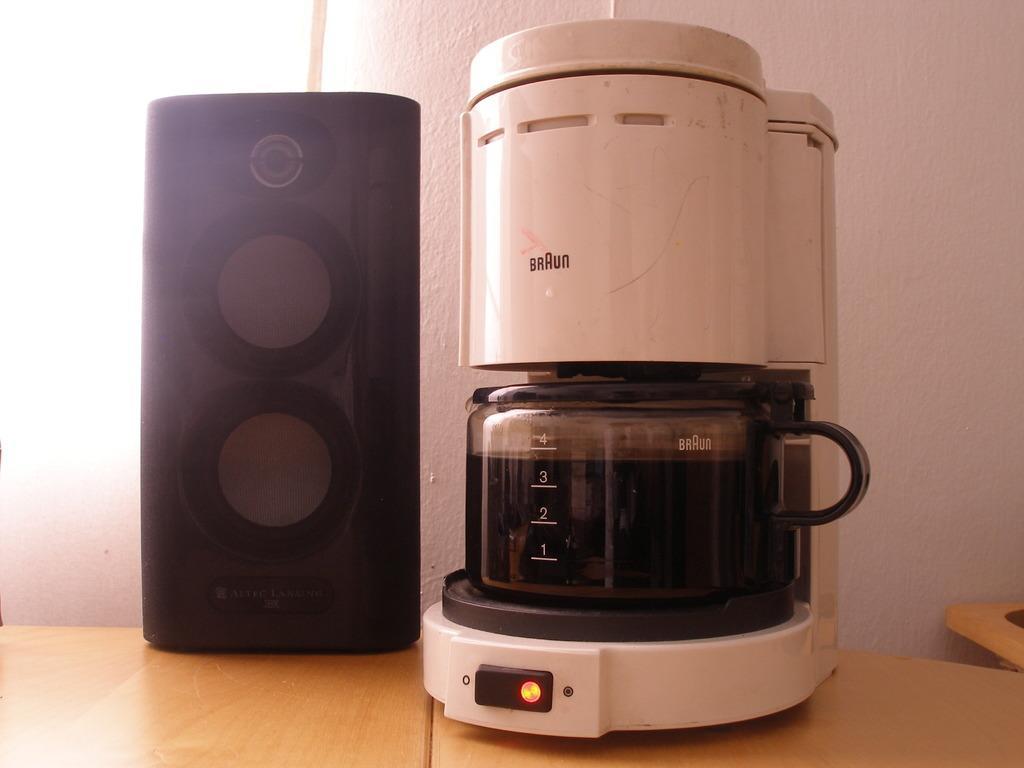Can you describe this image briefly? This picture is clicked inside. On the left we can see a black color speaker is placed on the top of the wooden table. On the right there is a white color electronic device which is placed on the top of the wooden table and we can see the text and numbers on the device. In the background we can see the wall. 